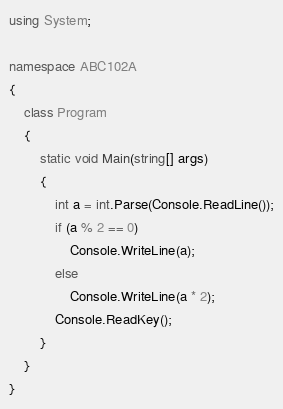Convert code to text. <code><loc_0><loc_0><loc_500><loc_500><_C#_>using System;

namespace ABC102A
{
    class Program
    {
        static void Main(string[] args)
        {
            int a = int.Parse(Console.ReadLine());
            if (a % 2 == 0)
                Console.WriteLine(a);
            else
                Console.WriteLine(a * 2);
            Console.ReadKey();
        }
    }
}
</code> 